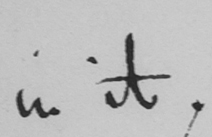Please provide the text content of this handwritten line. in it . 